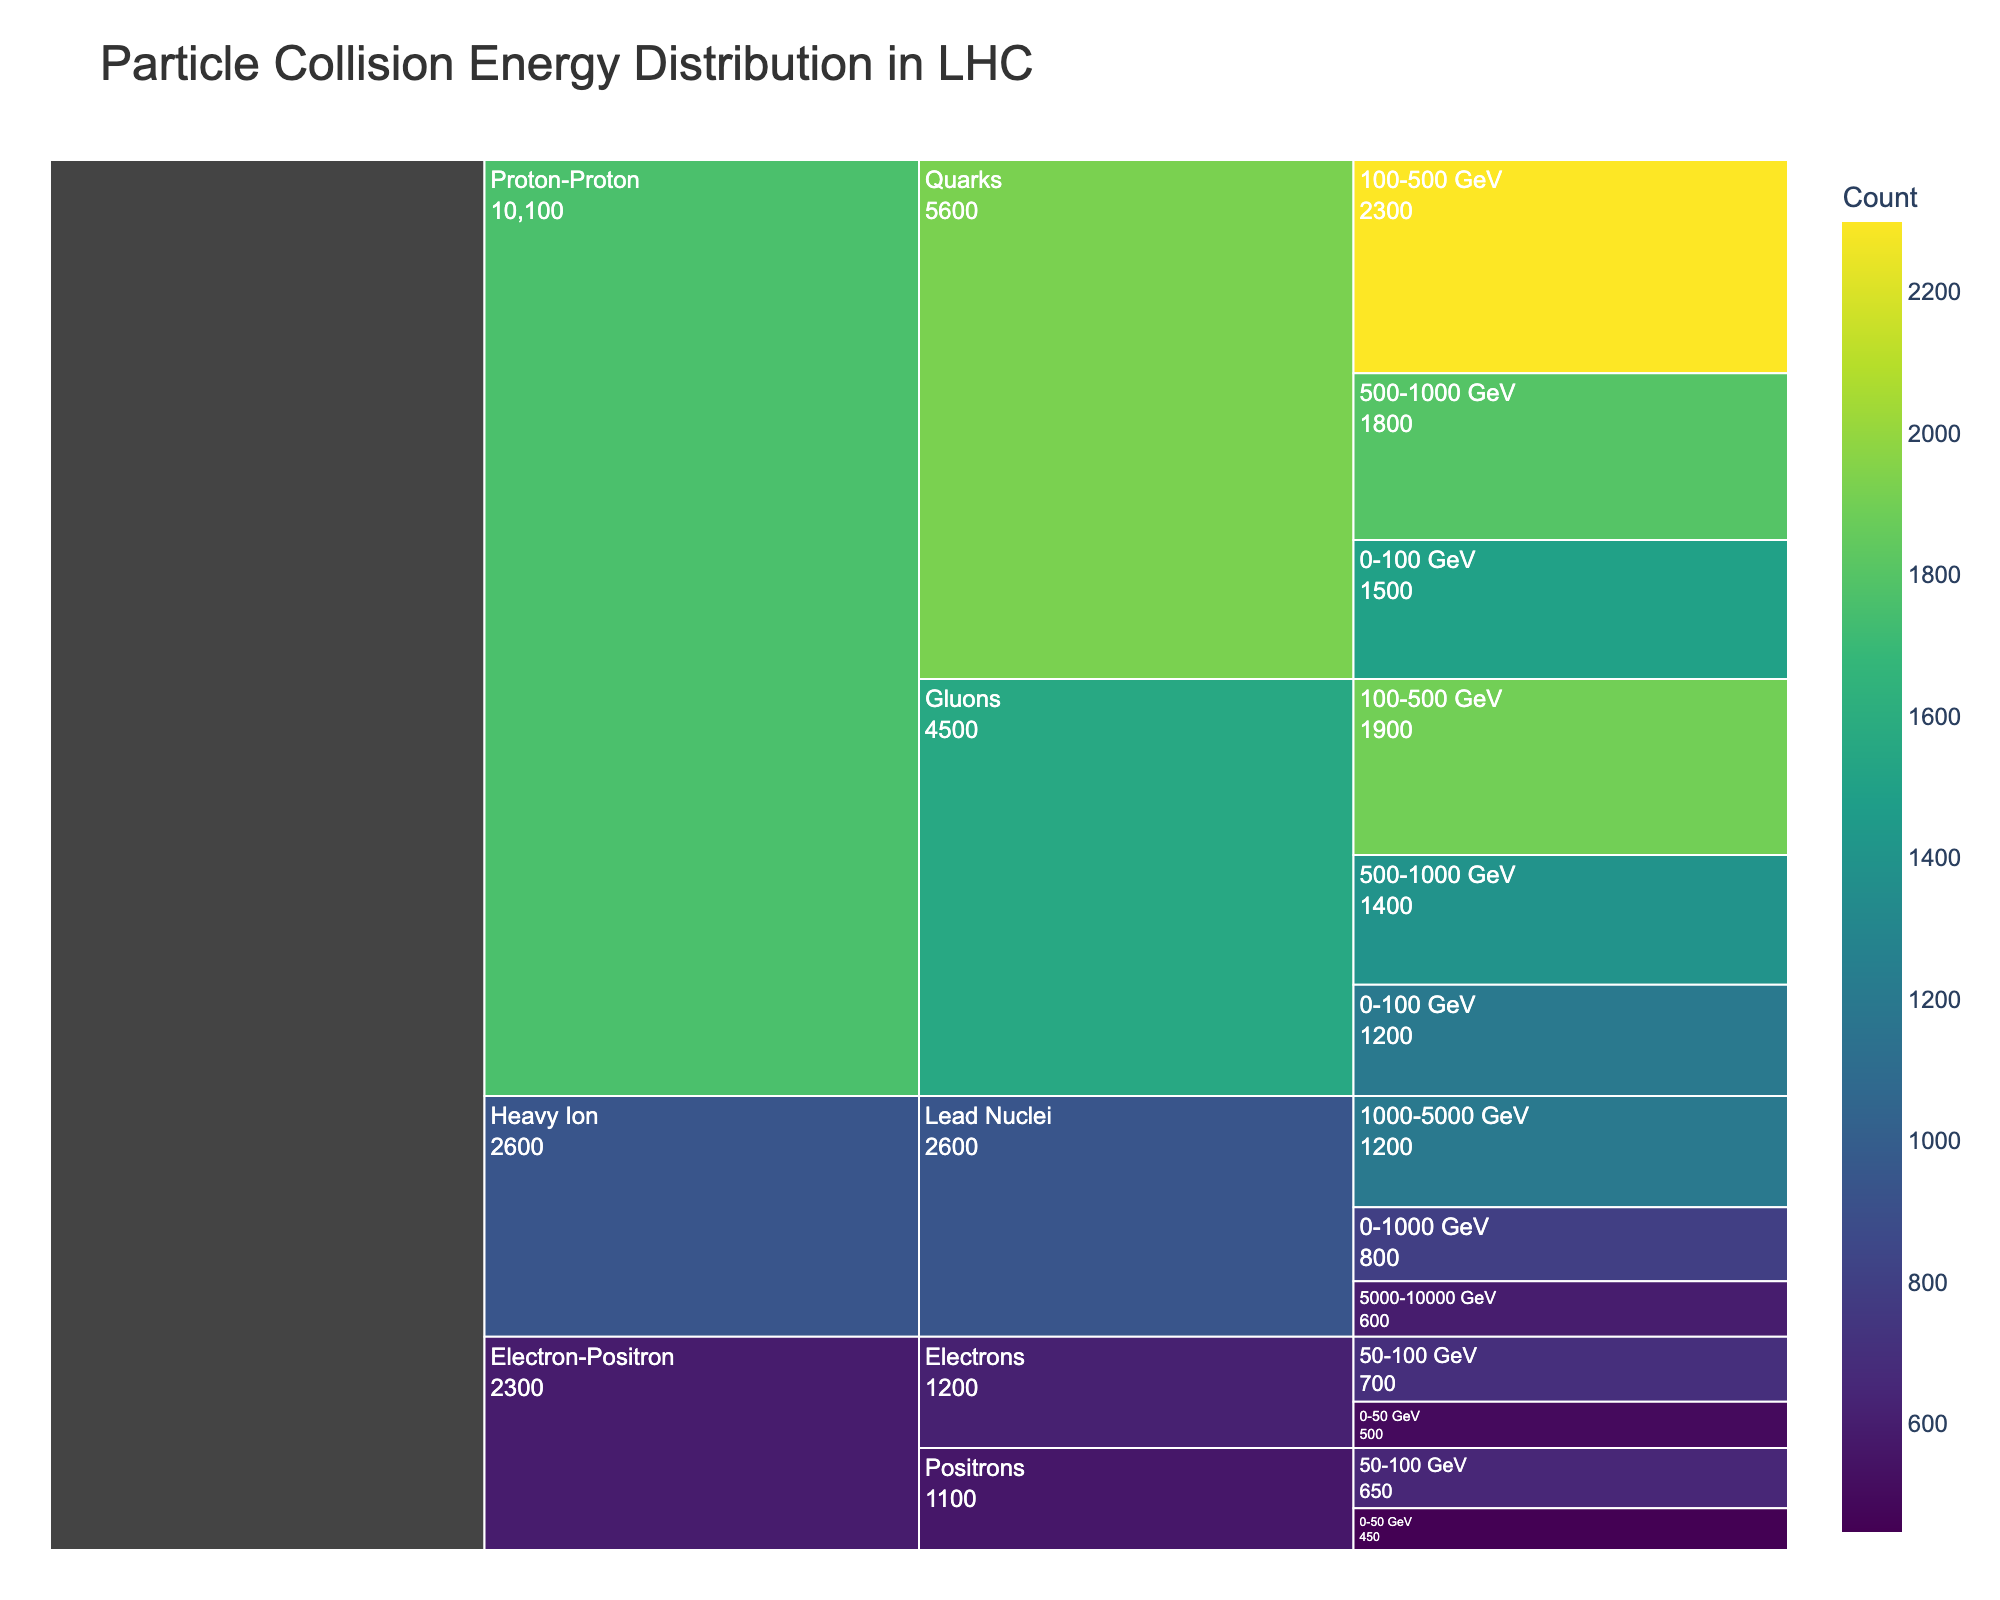What's the title of the icicle chart? The title of the icicle chart is written at the top of the figure, above the plot area. The title is "Particle Collision Energy Distribution in LHC."
Answer: Particle Collision Energy Distribution in LHC How many collision types are represented in the chart? The chart is divided into different sections, each beginning with a collision type. By counting these sections, we find there are three collision types: "Proton-Proton," "Heavy Ion," and "Electron-Positron."
Answer: 3 What particle species are associated with the "Proton-Proton" collision type? Under "Proton-Proton" collisions, the first level of categories represents particle species. These are "Quarks" and "Gluons."
Answer: Quarks and Gluons What is the total count of particles in the 100-500 GeV energy range for Proton-Proton collisions involving Quarks and Gluons? First, identify the counts for Quarks and Gluons in the 100-500 GeV range. For Quarks, it's 2300 and for Gluons, it's 1900. Summing these gives 2300 + 1900.
Answer: 4200 Which particle species has a count greater than 600 at any energy range in "Heavy Ion" collisions? Look under "Heavy Ion" collisions and examine the counts for each energy range for "Lead Nuclei." Only the 1000-5000 GeV range has a count greater than 600, specifically 1200.
Answer: Lead Nuclei Between "Electron-Positron" and "Heavy Ion" collisions, which has higher particle counts in their respective highest energy ranges shown? Compare the counts in the highest energy ranges shown for each collision type. For "Electron-Positron," the highest range is 50-100 GeV (700 and 650), and for "Heavy Ion," it's 5000-10000 GeV (600). Electron-Positron therefore has higher counts.
Answer: Electron-Positron What's the count difference between Quarks and Gluons in the 500-1000 GeV energy range for "Proton-Proton" collisions? Identify and subtract the counts: for Quarks, it's 1800, and for Gluons, it's 1400. The difference is 1800 - 1400.
Answer: 400 What is the most frequent particle energy range across all "Electron-Positron" collision species? Identify the highest count values within "Electron-Positron" data. The range with the highest counts is 50-100 GeV, with counts of 700 for Electrons and 650 for Positrons.
Answer: 50-100 GeV How many categories does each segment on the chart typically break into when viewed in full detail? Each top-level collision type category breaks into particle species, and each particle species further breaks into energy ranges. Typically, there are 2-4 segments at each breakdown level.
Answer: 2-4 